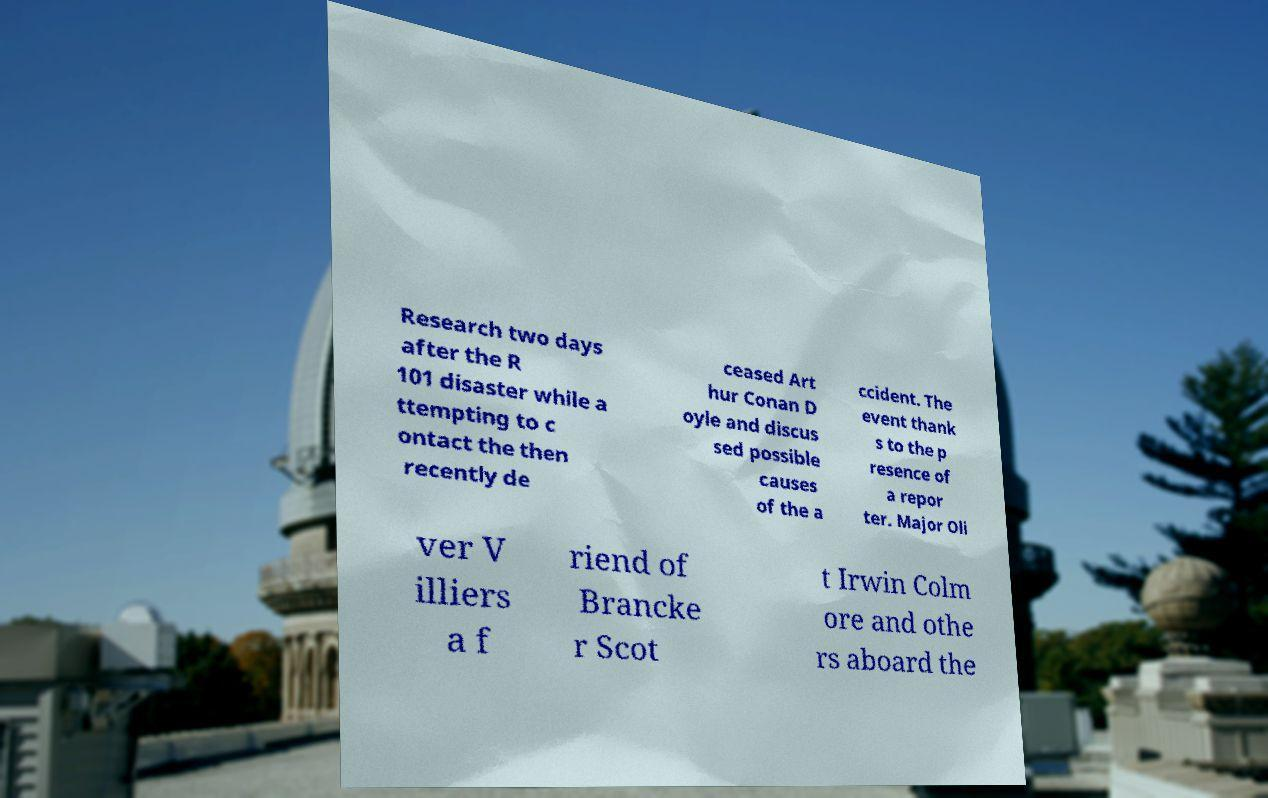Please identify and transcribe the text found in this image. Research two days after the R 101 disaster while a ttempting to c ontact the then recently de ceased Art hur Conan D oyle and discus sed possible causes of the a ccident. The event thank s to the p resence of a repor ter. Major Oli ver V illiers a f riend of Brancke r Scot t Irwin Colm ore and othe rs aboard the 